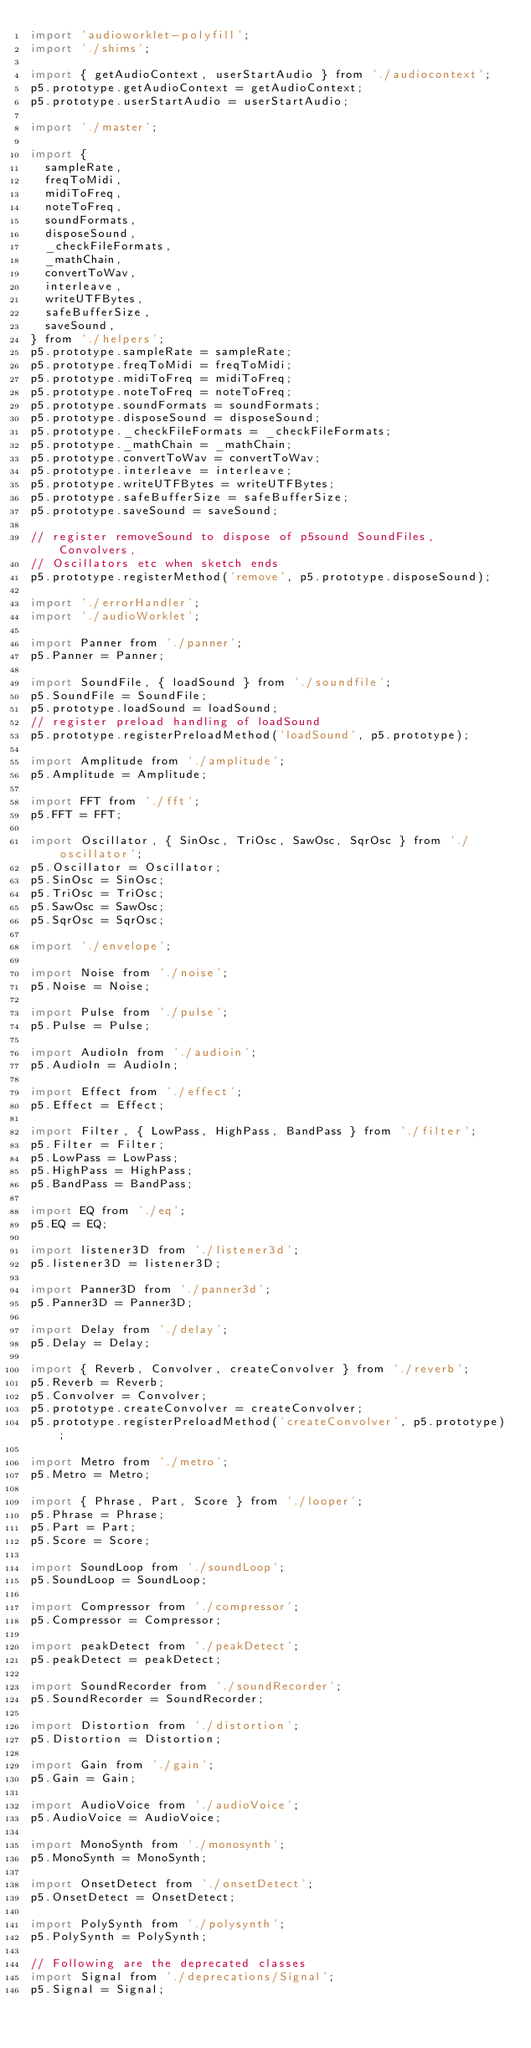<code> <loc_0><loc_0><loc_500><loc_500><_JavaScript_>import 'audioworklet-polyfill';
import './shims';

import { getAudioContext, userStartAudio } from './audiocontext';
p5.prototype.getAudioContext = getAudioContext;
p5.prototype.userStartAudio = userStartAudio;

import './master';

import {
  sampleRate,
  freqToMidi,
  midiToFreq,
  noteToFreq,
  soundFormats,
  disposeSound,
  _checkFileFormats,
  _mathChain,
  convertToWav,
  interleave,
  writeUTFBytes,
  safeBufferSize,
  saveSound,
} from './helpers';
p5.prototype.sampleRate = sampleRate;
p5.prototype.freqToMidi = freqToMidi;
p5.prototype.midiToFreq = midiToFreq;
p5.prototype.noteToFreq = noteToFreq;
p5.prototype.soundFormats = soundFormats;
p5.prototype.disposeSound = disposeSound;
p5.prototype._checkFileFormats = _checkFileFormats;
p5.prototype._mathChain = _mathChain;
p5.prototype.convertToWav = convertToWav;
p5.prototype.interleave = interleave;
p5.prototype.writeUTFBytes = writeUTFBytes;
p5.prototype.safeBufferSize = safeBufferSize;
p5.prototype.saveSound = saveSound;

// register removeSound to dispose of p5sound SoundFiles, Convolvers,
// Oscillators etc when sketch ends
p5.prototype.registerMethod('remove', p5.prototype.disposeSound);

import './errorHandler';
import './audioWorklet';

import Panner from './panner';
p5.Panner = Panner;

import SoundFile, { loadSound } from './soundfile';
p5.SoundFile = SoundFile;
p5.prototype.loadSound = loadSound;
// register preload handling of loadSound
p5.prototype.registerPreloadMethod('loadSound', p5.prototype);

import Amplitude from './amplitude';
p5.Amplitude = Amplitude;

import FFT from './fft';
p5.FFT = FFT;

import Oscillator, { SinOsc, TriOsc, SawOsc, SqrOsc } from './oscillator';
p5.Oscillator = Oscillator;
p5.SinOsc = SinOsc;
p5.TriOsc = TriOsc;
p5.SawOsc = SawOsc;
p5.SqrOsc = SqrOsc;

import './envelope';

import Noise from './noise';
p5.Noise = Noise;

import Pulse from './pulse';
p5.Pulse = Pulse;

import AudioIn from './audioin';
p5.AudioIn = AudioIn;

import Effect from './effect';
p5.Effect = Effect;

import Filter, { LowPass, HighPass, BandPass } from './filter';
p5.Filter = Filter;
p5.LowPass = LowPass;
p5.HighPass = HighPass;
p5.BandPass = BandPass;

import EQ from './eq';
p5.EQ = EQ;

import listener3D from './listener3d';
p5.listener3D = listener3D;

import Panner3D from './panner3d';
p5.Panner3D = Panner3D;

import Delay from './delay';
p5.Delay = Delay;

import { Reverb, Convolver, createConvolver } from './reverb';
p5.Reverb = Reverb;
p5.Convolver = Convolver;
p5.prototype.createConvolver = createConvolver;
p5.prototype.registerPreloadMethod('createConvolver', p5.prototype);

import Metro from './metro';
p5.Metro = Metro;

import { Phrase, Part, Score } from './looper';
p5.Phrase = Phrase;
p5.Part = Part;
p5.Score = Score;

import SoundLoop from './soundLoop';
p5.SoundLoop = SoundLoop;

import Compressor from './compressor';
p5.Compressor = Compressor;

import peakDetect from './peakDetect';
p5.peakDetect = peakDetect;

import SoundRecorder from './soundRecorder';
p5.SoundRecorder = SoundRecorder;

import Distortion from './distortion';
p5.Distortion = Distortion;

import Gain from './gain';
p5.Gain = Gain;

import AudioVoice from './audioVoice';
p5.AudioVoice = AudioVoice;

import MonoSynth from './monosynth';
p5.MonoSynth = MonoSynth;

import OnsetDetect from './onsetDetect';
p5.OnsetDetect = OnsetDetect;

import PolySynth from './polysynth';
p5.PolySynth = PolySynth;

// Following are the deprecated classes
import Signal from './deprecations/Signal';
p5.Signal = Signal;
</code> 